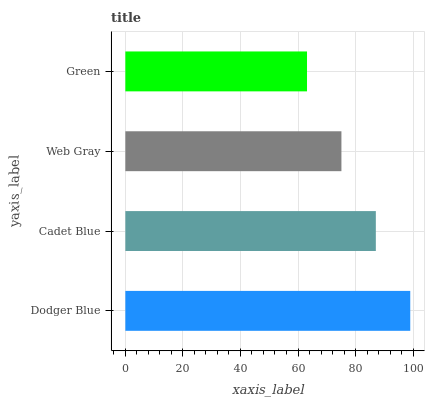Is Green the minimum?
Answer yes or no. Yes. Is Dodger Blue the maximum?
Answer yes or no. Yes. Is Cadet Blue the minimum?
Answer yes or no. No. Is Cadet Blue the maximum?
Answer yes or no. No. Is Dodger Blue greater than Cadet Blue?
Answer yes or no. Yes. Is Cadet Blue less than Dodger Blue?
Answer yes or no. Yes. Is Cadet Blue greater than Dodger Blue?
Answer yes or no. No. Is Dodger Blue less than Cadet Blue?
Answer yes or no. No. Is Cadet Blue the high median?
Answer yes or no. Yes. Is Web Gray the low median?
Answer yes or no. Yes. Is Dodger Blue the high median?
Answer yes or no. No. Is Green the low median?
Answer yes or no. No. 